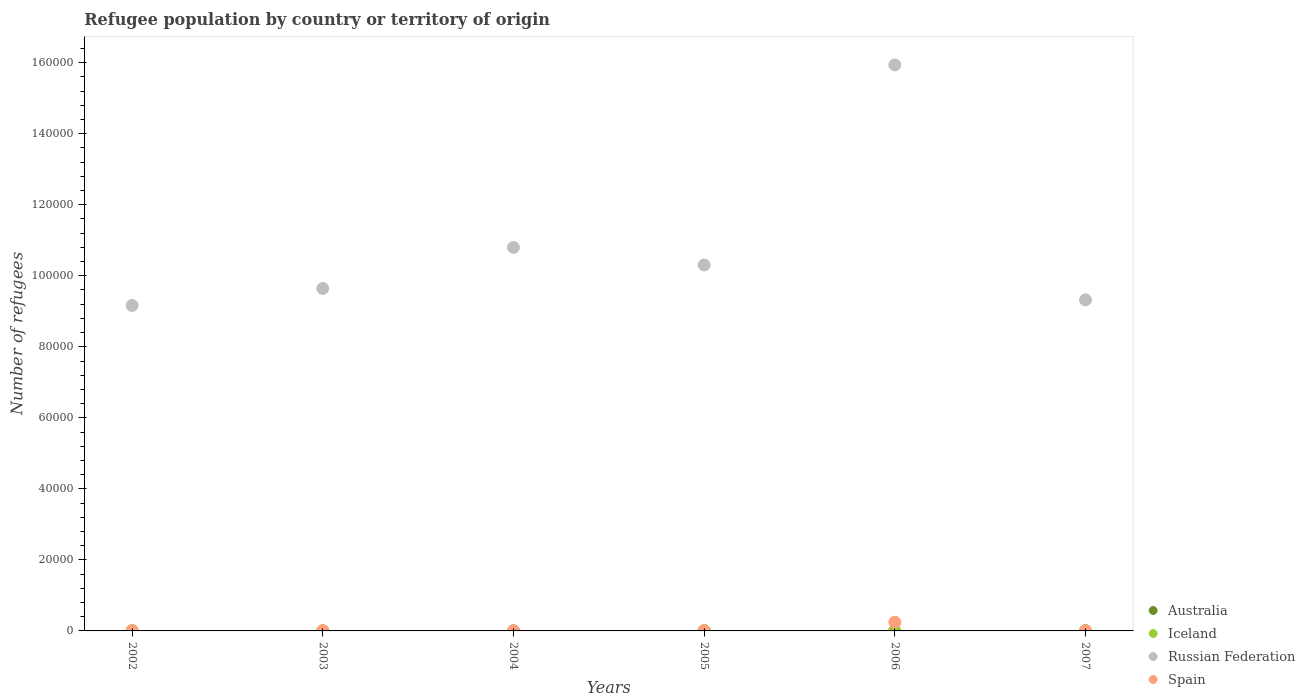In which year was the number of refugees in Australia maximum?
Offer a terse response. 2007. In which year was the number of refugees in Spain minimum?
Keep it short and to the point. 2007. What is the total number of refugees in Iceland in the graph?
Your answer should be very brief. 80. What is the difference between the number of refugees in Australia in 2003 and the number of refugees in Russian Federation in 2005?
Provide a short and direct response. -1.03e+05. In the year 2004, what is the difference between the number of refugees in Spain and number of refugees in Iceland?
Keep it short and to the point. 39. What is the ratio of the number of refugees in Iceland in 2002 to that in 2005?
Keep it short and to the point. 1.86. What is the difference between the highest and the second highest number of refugees in Russian Federation?
Give a very brief answer. 5.14e+04. What is the difference between the highest and the lowest number of refugees in Russian Federation?
Offer a very short reply. 6.78e+04. Is the sum of the number of refugees in Spain in 2003 and 2006 greater than the maximum number of refugees in Iceland across all years?
Make the answer very short. Yes. Is it the case that in every year, the sum of the number of refugees in Russian Federation and number of refugees in Iceland  is greater than the sum of number of refugees in Spain and number of refugees in Australia?
Offer a very short reply. Yes. Does the number of refugees in Spain monotonically increase over the years?
Your response must be concise. No. Is the number of refugees in Iceland strictly greater than the number of refugees in Australia over the years?
Provide a short and direct response. No. Is the number of refugees in Australia strictly less than the number of refugees in Iceland over the years?
Offer a very short reply. No. Are the values on the major ticks of Y-axis written in scientific E-notation?
Provide a short and direct response. No. Does the graph contain any zero values?
Offer a terse response. No. Does the graph contain grids?
Provide a succinct answer. No. How are the legend labels stacked?
Keep it short and to the point. Vertical. What is the title of the graph?
Your response must be concise. Refugee population by country or territory of origin. What is the label or title of the Y-axis?
Provide a short and direct response. Number of refugees. What is the Number of refugees of Iceland in 2002?
Your answer should be compact. 13. What is the Number of refugees in Russian Federation in 2002?
Provide a short and direct response. 9.16e+04. What is the Number of refugees of Australia in 2003?
Your answer should be very brief. 15. What is the Number of refugees in Russian Federation in 2003?
Give a very brief answer. 9.64e+04. What is the Number of refugees in Iceland in 2004?
Provide a short and direct response. 10. What is the Number of refugees in Russian Federation in 2004?
Provide a succinct answer. 1.08e+05. What is the Number of refugees of Spain in 2004?
Your answer should be compact. 49. What is the Number of refugees in Australia in 2005?
Give a very brief answer. 44. What is the Number of refugees in Iceland in 2005?
Offer a terse response. 7. What is the Number of refugees in Russian Federation in 2005?
Your answer should be compact. 1.03e+05. What is the Number of refugees in Russian Federation in 2006?
Keep it short and to the point. 1.59e+05. What is the Number of refugees of Spain in 2006?
Give a very brief answer. 2444. What is the Number of refugees of Iceland in 2007?
Your answer should be very brief. 7. What is the Number of refugees of Russian Federation in 2007?
Give a very brief answer. 9.32e+04. Across all years, what is the maximum Number of refugees of Australia?
Make the answer very short. 63. Across all years, what is the maximum Number of refugees in Russian Federation?
Your answer should be compact. 1.59e+05. Across all years, what is the maximum Number of refugees of Spain?
Your answer should be compact. 2444. Across all years, what is the minimum Number of refugees in Australia?
Offer a terse response. 10. Across all years, what is the minimum Number of refugees in Russian Federation?
Ensure brevity in your answer.  9.16e+04. What is the total Number of refugees in Australia in the graph?
Make the answer very short. 174. What is the total Number of refugees in Russian Federation in the graph?
Your answer should be very brief. 6.52e+05. What is the total Number of refugees in Spain in the graph?
Offer a very short reply. 2694. What is the difference between the Number of refugees in Australia in 2002 and that in 2003?
Offer a very short reply. -5. What is the difference between the Number of refugees of Iceland in 2002 and that in 2003?
Make the answer very short. 1. What is the difference between the Number of refugees in Russian Federation in 2002 and that in 2003?
Keep it short and to the point. -4794. What is the difference between the Number of refugees in Spain in 2002 and that in 2003?
Provide a short and direct response. 5. What is the difference between the Number of refugees in Iceland in 2002 and that in 2004?
Offer a terse response. 3. What is the difference between the Number of refugees of Russian Federation in 2002 and that in 2004?
Your answer should be compact. -1.63e+04. What is the difference between the Number of refugees of Australia in 2002 and that in 2005?
Your answer should be very brief. -34. What is the difference between the Number of refugees in Iceland in 2002 and that in 2005?
Your answer should be very brief. 6. What is the difference between the Number of refugees in Russian Federation in 2002 and that in 2005?
Make the answer very short. -1.14e+04. What is the difference between the Number of refugees in Spain in 2002 and that in 2005?
Your answer should be very brief. 9. What is the difference between the Number of refugees of Australia in 2002 and that in 2006?
Your response must be concise. -19. What is the difference between the Number of refugees of Russian Federation in 2002 and that in 2006?
Your response must be concise. -6.78e+04. What is the difference between the Number of refugees in Spain in 2002 and that in 2006?
Provide a succinct answer. -2386. What is the difference between the Number of refugees in Australia in 2002 and that in 2007?
Offer a very short reply. -53. What is the difference between the Number of refugees of Iceland in 2002 and that in 2007?
Provide a short and direct response. 6. What is the difference between the Number of refugees in Russian Federation in 2002 and that in 2007?
Ensure brevity in your answer.  -1598. What is the difference between the Number of refugees in Iceland in 2003 and that in 2004?
Your response must be concise. 2. What is the difference between the Number of refugees in Russian Federation in 2003 and that in 2004?
Offer a very short reply. -1.16e+04. What is the difference between the Number of refugees of Spain in 2003 and that in 2004?
Make the answer very short. 4. What is the difference between the Number of refugees in Iceland in 2003 and that in 2005?
Keep it short and to the point. 5. What is the difference between the Number of refugees in Russian Federation in 2003 and that in 2005?
Offer a terse response. -6617. What is the difference between the Number of refugees of Iceland in 2003 and that in 2006?
Your response must be concise. -19. What is the difference between the Number of refugees in Russian Federation in 2003 and that in 2006?
Offer a terse response. -6.30e+04. What is the difference between the Number of refugees in Spain in 2003 and that in 2006?
Make the answer very short. -2391. What is the difference between the Number of refugees in Australia in 2003 and that in 2007?
Ensure brevity in your answer.  -48. What is the difference between the Number of refugees of Iceland in 2003 and that in 2007?
Offer a terse response. 5. What is the difference between the Number of refugees of Russian Federation in 2003 and that in 2007?
Provide a short and direct response. 3196. What is the difference between the Number of refugees in Spain in 2003 and that in 2007?
Offer a terse response. 12. What is the difference between the Number of refugees of Australia in 2004 and that in 2005?
Your answer should be very brief. -31. What is the difference between the Number of refugees in Iceland in 2004 and that in 2005?
Ensure brevity in your answer.  3. What is the difference between the Number of refugees of Russian Federation in 2004 and that in 2005?
Provide a short and direct response. 4938. What is the difference between the Number of refugees of Australia in 2004 and that in 2006?
Offer a terse response. -16. What is the difference between the Number of refugees in Iceland in 2004 and that in 2006?
Your answer should be very brief. -21. What is the difference between the Number of refugees of Russian Federation in 2004 and that in 2006?
Keep it short and to the point. -5.14e+04. What is the difference between the Number of refugees of Spain in 2004 and that in 2006?
Offer a very short reply. -2395. What is the difference between the Number of refugees in Australia in 2004 and that in 2007?
Make the answer very short. -50. What is the difference between the Number of refugees in Russian Federation in 2004 and that in 2007?
Your response must be concise. 1.48e+04. What is the difference between the Number of refugees of Spain in 2004 and that in 2007?
Your response must be concise. 8. What is the difference between the Number of refugees in Australia in 2005 and that in 2006?
Your answer should be very brief. 15. What is the difference between the Number of refugees in Iceland in 2005 and that in 2006?
Make the answer very short. -24. What is the difference between the Number of refugees in Russian Federation in 2005 and that in 2006?
Offer a terse response. -5.63e+04. What is the difference between the Number of refugees of Spain in 2005 and that in 2006?
Your answer should be very brief. -2395. What is the difference between the Number of refugees in Iceland in 2005 and that in 2007?
Ensure brevity in your answer.  0. What is the difference between the Number of refugees in Russian Federation in 2005 and that in 2007?
Your answer should be compact. 9813. What is the difference between the Number of refugees of Australia in 2006 and that in 2007?
Keep it short and to the point. -34. What is the difference between the Number of refugees of Iceland in 2006 and that in 2007?
Your answer should be very brief. 24. What is the difference between the Number of refugees in Russian Federation in 2006 and that in 2007?
Your response must be concise. 6.62e+04. What is the difference between the Number of refugees of Spain in 2006 and that in 2007?
Provide a succinct answer. 2403. What is the difference between the Number of refugees in Australia in 2002 and the Number of refugees in Iceland in 2003?
Provide a succinct answer. -2. What is the difference between the Number of refugees in Australia in 2002 and the Number of refugees in Russian Federation in 2003?
Keep it short and to the point. -9.64e+04. What is the difference between the Number of refugees in Australia in 2002 and the Number of refugees in Spain in 2003?
Provide a short and direct response. -43. What is the difference between the Number of refugees of Iceland in 2002 and the Number of refugees of Russian Federation in 2003?
Provide a short and direct response. -9.64e+04. What is the difference between the Number of refugees in Iceland in 2002 and the Number of refugees in Spain in 2003?
Your response must be concise. -40. What is the difference between the Number of refugees in Russian Federation in 2002 and the Number of refugees in Spain in 2003?
Make the answer very short. 9.16e+04. What is the difference between the Number of refugees in Australia in 2002 and the Number of refugees in Iceland in 2004?
Ensure brevity in your answer.  0. What is the difference between the Number of refugees in Australia in 2002 and the Number of refugees in Russian Federation in 2004?
Your answer should be compact. -1.08e+05. What is the difference between the Number of refugees in Australia in 2002 and the Number of refugees in Spain in 2004?
Provide a succinct answer. -39. What is the difference between the Number of refugees of Iceland in 2002 and the Number of refugees of Russian Federation in 2004?
Ensure brevity in your answer.  -1.08e+05. What is the difference between the Number of refugees in Iceland in 2002 and the Number of refugees in Spain in 2004?
Make the answer very short. -36. What is the difference between the Number of refugees in Russian Federation in 2002 and the Number of refugees in Spain in 2004?
Keep it short and to the point. 9.16e+04. What is the difference between the Number of refugees in Australia in 2002 and the Number of refugees in Russian Federation in 2005?
Offer a very short reply. -1.03e+05. What is the difference between the Number of refugees of Australia in 2002 and the Number of refugees of Spain in 2005?
Provide a short and direct response. -39. What is the difference between the Number of refugees in Iceland in 2002 and the Number of refugees in Russian Federation in 2005?
Offer a very short reply. -1.03e+05. What is the difference between the Number of refugees in Iceland in 2002 and the Number of refugees in Spain in 2005?
Give a very brief answer. -36. What is the difference between the Number of refugees of Russian Federation in 2002 and the Number of refugees of Spain in 2005?
Make the answer very short. 9.16e+04. What is the difference between the Number of refugees of Australia in 2002 and the Number of refugees of Russian Federation in 2006?
Provide a short and direct response. -1.59e+05. What is the difference between the Number of refugees in Australia in 2002 and the Number of refugees in Spain in 2006?
Your answer should be compact. -2434. What is the difference between the Number of refugees of Iceland in 2002 and the Number of refugees of Russian Federation in 2006?
Provide a short and direct response. -1.59e+05. What is the difference between the Number of refugees of Iceland in 2002 and the Number of refugees of Spain in 2006?
Your response must be concise. -2431. What is the difference between the Number of refugees in Russian Federation in 2002 and the Number of refugees in Spain in 2006?
Make the answer very short. 8.92e+04. What is the difference between the Number of refugees in Australia in 2002 and the Number of refugees in Iceland in 2007?
Make the answer very short. 3. What is the difference between the Number of refugees in Australia in 2002 and the Number of refugees in Russian Federation in 2007?
Provide a succinct answer. -9.32e+04. What is the difference between the Number of refugees in Australia in 2002 and the Number of refugees in Spain in 2007?
Your answer should be very brief. -31. What is the difference between the Number of refugees of Iceland in 2002 and the Number of refugees of Russian Federation in 2007?
Give a very brief answer. -9.32e+04. What is the difference between the Number of refugees of Iceland in 2002 and the Number of refugees of Spain in 2007?
Offer a very short reply. -28. What is the difference between the Number of refugees of Russian Federation in 2002 and the Number of refugees of Spain in 2007?
Your response must be concise. 9.16e+04. What is the difference between the Number of refugees of Australia in 2003 and the Number of refugees of Iceland in 2004?
Provide a succinct answer. 5. What is the difference between the Number of refugees of Australia in 2003 and the Number of refugees of Russian Federation in 2004?
Give a very brief answer. -1.08e+05. What is the difference between the Number of refugees of Australia in 2003 and the Number of refugees of Spain in 2004?
Provide a short and direct response. -34. What is the difference between the Number of refugees of Iceland in 2003 and the Number of refugees of Russian Federation in 2004?
Your response must be concise. -1.08e+05. What is the difference between the Number of refugees in Iceland in 2003 and the Number of refugees in Spain in 2004?
Make the answer very short. -37. What is the difference between the Number of refugees of Russian Federation in 2003 and the Number of refugees of Spain in 2004?
Give a very brief answer. 9.64e+04. What is the difference between the Number of refugees of Australia in 2003 and the Number of refugees of Iceland in 2005?
Give a very brief answer. 8. What is the difference between the Number of refugees in Australia in 2003 and the Number of refugees in Russian Federation in 2005?
Offer a very short reply. -1.03e+05. What is the difference between the Number of refugees in Australia in 2003 and the Number of refugees in Spain in 2005?
Your response must be concise. -34. What is the difference between the Number of refugees in Iceland in 2003 and the Number of refugees in Russian Federation in 2005?
Offer a very short reply. -1.03e+05. What is the difference between the Number of refugees of Iceland in 2003 and the Number of refugees of Spain in 2005?
Provide a succinct answer. -37. What is the difference between the Number of refugees in Russian Federation in 2003 and the Number of refugees in Spain in 2005?
Keep it short and to the point. 9.64e+04. What is the difference between the Number of refugees of Australia in 2003 and the Number of refugees of Russian Federation in 2006?
Make the answer very short. -1.59e+05. What is the difference between the Number of refugees in Australia in 2003 and the Number of refugees in Spain in 2006?
Offer a terse response. -2429. What is the difference between the Number of refugees of Iceland in 2003 and the Number of refugees of Russian Federation in 2006?
Provide a succinct answer. -1.59e+05. What is the difference between the Number of refugees in Iceland in 2003 and the Number of refugees in Spain in 2006?
Provide a short and direct response. -2432. What is the difference between the Number of refugees in Russian Federation in 2003 and the Number of refugees in Spain in 2006?
Your answer should be very brief. 9.40e+04. What is the difference between the Number of refugees of Australia in 2003 and the Number of refugees of Iceland in 2007?
Keep it short and to the point. 8. What is the difference between the Number of refugees in Australia in 2003 and the Number of refugees in Russian Federation in 2007?
Keep it short and to the point. -9.32e+04. What is the difference between the Number of refugees of Australia in 2003 and the Number of refugees of Spain in 2007?
Provide a succinct answer. -26. What is the difference between the Number of refugees of Iceland in 2003 and the Number of refugees of Russian Federation in 2007?
Offer a very short reply. -9.32e+04. What is the difference between the Number of refugees in Russian Federation in 2003 and the Number of refugees in Spain in 2007?
Provide a short and direct response. 9.64e+04. What is the difference between the Number of refugees in Australia in 2004 and the Number of refugees in Russian Federation in 2005?
Make the answer very short. -1.03e+05. What is the difference between the Number of refugees of Australia in 2004 and the Number of refugees of Spain in 2005?
Keep it short and to the point. -36. What is the difference between the Number of refugees of Iceland in 2004 and the Number of refugees of Russian Federation in 2005?
Your answer should be compact. -1.03e+05. What is the difference between the Number of refugees of Iceland in 2004 and the Number of refugees of Spain in 2005?
Provide a short and direct response. -39. What is the difference between the Number of refugees of Russian Federation in 2004 and the Number of refugees of Spain in 2005?
Your answer should be compact. 1.08e+05. What is the difference between the Number of refugees of Australia in 2004 and the Number of refugees of Russian Federation in 2006?
Your answer should be compact. -1.59e+05. What is the difference between the Number of refugees in Australia in 2004 and the Number of refugees in Spain in 2006?
Offer a terse response. -2431. What is the difference between the Number of refugees of Iceland in 2004 and the Number of refugees of Russian Federation in 2006?
Provide a short and direct response. -1.59e+05. What is the difference between the Number of refugees in Iceland in 2004 and the Number of refugees in Spain in 2006?
Your answer should be very brief. -2434. What is the difference between the Number of refugees in Russian Federation in 2004 and the Number of refugees in Spain in 2006?
Offer a very short reply. 1.06e+05. What is the difference between the Number of refugees in Australia in 2004 and the Number of refugees in Russian Federation in 2007?
Provide a succinct answer. -9.32e+04. What is the difference between the Number of refugees of Iceland in 2004 and the Number of refugees of Russian Federation in 2007?
Offer a very short reply. -9.32e+04. What is the difference between the Number of refugees in Iceland in 2004 and the Number of refugees in Spain in 2007?
Offer a very short reply. -31. What is the difference between the Number of refugees in Russian Federation in 2004 and the Number of refugees in Spain in 2007?
Your response must be concise. 1.08e+05. What is the difference between the Number of refugees of Australia in 2005 and the Number of refugees of Iceland in 2006?
Your answer should be compact. 13. What is the difference between the Number of refugees in Australia in 2005 and the Number of refugees in Russian Federation in 2006?
Offer a terse response. -1.59e+05. What is the difference between the Number of refugees in Australia in 2005 and the Number of refugees in Spain in 2006?
Your response must be concise. -2400. What is the difference between the Number of refugees of Iceland in 2005 and the Number of refugees of Russian Federation in 2006?
Your answer should be compact. -1.59e+05. What is the difference between the Number of refugees in Iceland in 2005 and the Number of refugees in Spain in 2006?
Your response must be concise. -2437. What is the difference between the Number of refugees in Russian Federation in 2005 and the Number of refugees in Spain in 2006?
Provide a short and direct response. 1.01e+05. What is the difference between the Number of refugees in Australia in 2005 and the Number of refugees in Russian Federation in 2007?
Give a very brief answer. -9.32e+04. What is the difference between the Number of refugees of Iceland in 2005 and the Number of refugees of Russian Federation in 2007?
Provide a succinct answer. -9.32e+04. What is the difference between the Number of refugees of Iceland in 2005 and the Number of refugees of Spain in 2007?
Provide a short and direct response. -34. What is the difference between the Number of refugees of Russian Federation in 2005 and the Number of refugees of Spain in 2007?
Keep it short and to the point. 1.03e+05. What is the difference between the Number of refugees of Australia in 2006 and the Number of refugees of Iceland in 2007?
Your response must be concise. 22. What is the difference between the Number of refugees in Australia in 2006 and the Number of refugees in Russian Federation in 2007?
Your response must be concise. -9.32e+04. What is the difference between the Number of refugees of Australia in 2006 and the Number of refugees of Spain in 2007?
Offer a very short reply. -12. What is the difference between the Number of refugees in Iceland in 2006 and the Number of refugees in Russian Federation in 2007?
Your answer should be compact. -9.32e+04. What is the difference between the Number of refugees of Russian Federation in 2006 and the Number of refugees of Spain in 2007?
Provide a succinct answer. 1.59e+05. What is the average Number of refugees of Iceland per year?
Ensure brevity in your answer.  13.33. What is the average Number of refugees in Russian Federation per year?
Your answer should be very brief. 1.09e+05. What is the average Number of refugees of Spain per year?
Your response must be concise. 449. In the year 2002, what is the difference between the Number of refugees of Australia and Number of refugees of Iceland?
Ensure brevity in your answer.  -3. In the year 2002, what is the difference between the Number of refugees in Australia and Number of refugees in Russian Federation?
Give a very brief answer. -9.16e+04. In the year 2002, what is the difference between the Number of refugees of Australia and Number of refugees of Spain?
Provide a short and direct response. -48. In the year 2002, what is the difference between the Number of refugees of Iceland and Number of refugees of Russian Federation?
Provide a succinct answer. -9.16e+04. In the year 2002, what is the difference between the Number of refugees of Iceland and Number of refugees of Spain?
Offer a terse response. -45. In the year 2002, what is the difference between the Number of refugees of Russian Federation and Number of refugees of Spain?
Your answer should be compact. 9.16e+04. In the year 2003, what is the difference between the Number of refugees of Australia and Number of refugees of Russian Federation?
Give a very brief answer. -9.64e+04. In the year 2003, what is the difference between the Number of refugees in Australia and Number of refugees in Spain?
Your response must be concise. -38. In the year 2003, what is the difference between the Number of refugees of Iceland and Number of refugees of Russian Federation?
Keep it short and to the point. -9.64e+04. In the year 2003, what is the difference between the Number of refugees in Iceland and Number of refugees in Spain?
Provide a short and direct response. -41. In the year 2003, what is the difference between the Number of refugees in Russian Federation and Number of refugees in Spain?
Your response must be concise. 9.64e+04. In the year 2004, what is the difference between the Number of refugees in Australia and Number of refugees in Iceland?
Your answer should be very brief. 3. In the year 2004, what is the difference between the Number of refugees of Australia and Number of refugees of Russian Federation?
Provide a short and direct response. -1.08e+05. In the year 2004, what is the difference between the Number of refugees of Australia and Number of refugees of Spain?
Give a very brief answer. -36. In the year 2004, what is the difference between the Number of refugees in Iceland and Number of refugees in Russian Federation?
Offer a terse response. -1.08e+05. In the year 2004, what is the difference between the Number of refugees in Iceland and Number of refugees in Spain?
Keep it short and to the point. -39. In the year 2004, what is the difference between the Number of refugees in Russian Federation and Number of refugees in Spain?
Offer a very short reply. 1.08e+05. In the year 2005, what is the difference between the Number of refugees of Australia and Number of refugees of Iceland?
Your answer should be very brief. 37. In the year 2005, what is the difference between the Number of refugees in Australia and Number of refugees in Russian Federation?
Keep it short and to the point. -1.03e+05. In the year 2005, what is the difference between the Number of refugees of Australia and Number of refugees of Spain?
Give a very brief answer. -5. In the year 2005, what is the difference between the Number of refugees in Iceland and Number of refugees in Russian Federation?
Offer a terse response. -1.03e+05. In the year 2005, what is the difference between the Number of refugees in Iceland and Number of refugees in Spain?
Make the answer very short. -42. In the year 2005, what is the difference between the Number of refugees of Russian Federation and Number of refugees of Spain?
Ensure brevity in your answer.  1.03e+05. In the year 2006, what is the difference between the Number of refugees in Australia and Number of refugees in Russian Federation?
Offer a very short reply. -1.59e+05. In the year 2006, what is the difference between the Number of refugees in Australia and Number of refugees in Spain?
Make the answer very short. -2415. In the year 2006, what is the difference between the Number of refugees in Iceland and Number of refugees in Russian Federation?
Your answer should be compact. -1.59e+05. In the year 2006, what is the difference between the Number of refugees in Iceland and Number of refugees in Spain?
Your answer should be compact. -2413. In the year 2006, what is the difference between the Number of refugees of Russian Federation and Number of refugees of Spain?
Offer a terse response. 1.57e+05. In the year 2007, what is the difference between the Number of refugees in Australia and Number of refugees in Iceland?
Your answer should be compact. 56. In the year 2007, what is the difference between the Number of refugees in Australia and Number of refugees in Russian Federation?
Offer a terse response. -9.32e+04. In the year 2007, what is the difference between the Number of refugees of Australia and Number of refugees of Spain?
Your answer should be compact. 22. In the year 2007, what is the difference between the Number of refugees in Iceland and Number of refugees in Russian Federation?
Keep it short and to the point. -9.32e+04. In the year 2007, what is the difference between the Number of refugees in Iceland and Number of refugees in Spain?
Offer a very short reply. -34. In the year 2007, what is the difference between the Number of refugees in Russian Federation and Number of refugees in Spain?
Offer a very short reply. 9.32e+04. What is the ratio of the Number of refugees of Australia in 2002 to that in 2003?
Offer a terse response. 0.67. What is the ratio of the Number of refugees in Russian Federation in 2002 to that in 2003?
Offer a terse response. 0.95. What is the ratio of the Number of refugees in Spain in 2002 to that in 2003?
Give a very brief answer. 1.09. What is the ratio of the Number of refugees in Australia in 2002 to that in 2004?
Give a very brief answer. 0.77. What is the ratio of the Number of refugees in Russian Federation in 2002 to that in 2004?
Provide a succinct answer. 0.85. What is the ratio of the Number of refugees of Spain in 2002 to that in 2004?
Give a very brief answer. 1.18. What is the ratio of the Number of refugees in Australia in 2002 to that in 2005?
Provide a short and direct response. 0.23. What is the ratio of the Number of refugees in Iceland in 2002 to that in 2005?
Keep it short and to the point. 1.86. What is the ratio of the Number of refugees in Russian Federation in 2002 to that in 2005?
Your response must be concise. 0.89. What is the ratio of the Number of refugees in Spain in 2002 to that in 2005?
Give a very brief answer. 1.18. What is the ratio of the Number of refugees of Australia in 2002 to that in 2006?
Your response must be concise. 0.34. What is the ratio of the Number of refugees in Iceland in 2002 to that in 2006?
Provide a short and direct response. 0.42. What is the ratio of the Number of refugees in Russian Federation in 2002 to that in 2006?
Make the answer very short. 0.57. What is the ratio of the Number of refugees in Spain in 2002 to that in 2006?
Your response must be concise. 0.02. What is the ratio of the Number of refugees of Australia in 2002 to that in 2007?
Make the answer very short. 0.16. What is the ratio of the Number of refugees in Iceland in 2002 to that in 2007?
Give a very brief answer. 1.86. What is the ratio of the Number of refugees in Russian Federation in 2002 to that in 2007?
Give a very brief answer. 0.98. What is the ratio of the Number of refugees of Spain in 2002 to that in 2007?
Keep it short and to the point. 1.41. What is the ratio of the Number of refugees in Australia in 2003 to that in 2004?
Your answer should be very brief. 1.15. What is the ratio of the Number of refugees in Russian Federation in 2003 to that in 2004?
Keep it short and to the point. 0.89. What is the ratio of the Number of refugees of Spain in 2003 to that in 2004?
Keep it short and to the point. 1.08. What is the ratio of the Number of refugees of Australia in 2003 to that in 2005?
Your response must be concise. 0.34. What is the ratio of the Number of refugees in Iceland in 2003 to that in 2005?
Ensure brevity in your answer.  1.71. What is the ratio of the Number of refugees in Russian Federation in 2003 to that in 2005?
Offer a terse response. 0.94. What is the ratio of the Number of refugees of Spain in 2003 to that in 2005?
Ensure brevity in your answer.  1.08. What is the ratio of the Number of refugees of Australia in 2003 to that in 2006?
Make the answer very short. 0.52. What is the ratio of the Number of refugees in Iceland in 2003 to that in 2006?
Offer a very short reply. 0.39. What is the ratio of the Number of refugees in Russian Federation in 2003 to that in 2006?
Make the answer very short. 0.6. What is the ratio of the Number of refugees of Spain in 2003 to that in 2006?
Ensure brevity in your answer.  0.02. What is the ratio of the Number of refugees of Australia in 2003 to that in 2007?
Offer a very short reply. 0.24. What is the ratio of the Number of refugees of Iceland in 2003 to that in 2007?
Make the answer very short. 1.71. What is the ratio of the Number of refugees in Russian Federation in 2003 to that in 2007?
Provide a succinct answer. 1.03. What is the ratio of the Number of refugees in Spain in 2003 to that in 2007?
Give a very brief answer. 1.29. What is the ratio of the Number of refugees in Australia in 2004 to that in 2005?
Your answer should be very brief. 0.3. What is the ratio of the Number of refugees in Iceland in 2004 to that in 2005?
Provide a succinct answer. 1.43. What is the ratio of the Number of refugees in Russian Federation in 2004 to that in 2005?
Keep it short and to the point. 1.05. What is the ratio of the Number of refugees of Spain in 2004 to that in 2005?
Your answer should be compact. 1. What is the ratio of the Number of refugees in Australia in 2004 to that in 2006?
Offer a terse response. 0.45. What is the ratio of the Number of refugees of Iceland in 2004 to that in 2006?
Give a very brief answer. 0.32. What is the ratio of the Number of refugees of Russian Federation in 2004 to that in 2006?
Provide a short and direct response. 0.68. What is the ratio of the Number of refugees of Spain in 2004 to that in 2006?
Your answer should be very brief. 0.02. What is the ratio of the Number of refugees in Australia in 2004 to that in 2007?
Keep it short and to the point. 0.21. What is the ratio of the Number of refugees of Iceland in 2004 to that in 2007?
Ensure brevity in your answer.  1.43. What is the ratio of the Number of refugees of Russian Federation in 2004 to that in 2007?
Provide a succinct answer. 1.16. What is the ratio of the Number of refugees of Spain in 2004 to that in 2007?
Offer a terse response. 1.2. What is the ratio of the Number of refugees in Australia in 2005 to that in 2006?
Offer a very short reply. 1.52. What is the ratio of the Number of refugees of Iceland in 2005 to that in 2006?
Keep it short and to the point. 0.23. What is the ratio of the Number of refugees of Russian Federation in 2005 to that in 2006?
Make the answer very short. 0.65. What is the ratio of the Number of refugees in Spain in 2005 to that in 2006?
Provide a short and direct response. 0.02. What is the ratio of the Number of refugees of Australia in 2005 to that in 2007?
Give a very brief answer. 0.7. What is the ratio of the Number of refugees of Iceland in 2005 to that in 2007?
Your answer should be very brief. 1. What is the ratio of the Number of refugees of Russian Federation in 2005 to that in 2007?
Provide a succinct answer. 1.11. What is the ratio of the Number of refugees in Spain in 2005 to that in 2007?
Your answer should be compact. 1.2. What is the ratio of the Number of refugees of Australia in 2006 to that in 2007?
Your response must be concise. 0.46. What is the ratio of the Number of refugees of Iceland in 2006 to that in 2007?
Give a very brief answer. 4.43. What is the ratio of the Number of refugees of Russian Federation in 2006 to that in 2007?
Keep it short and to the point. 1.71. What is the ratio of the Number of refugees in Spain in 2006 to that in 2007?
Keep it short and to the point. 59.61. What is the difference between the highest and the second highest Number of refugees in Australia?
Provide a short and direct response. 19. What is the difference between the highest and the second highest Number of refugees of Russian Federation?
Offer a very short reply. 5.14e+04. What is the difference between the highest and the second highest Number of refugees in Spain?
Make the answer very short. 2386. What is the difference between the highest and the lowest Number of refugees in Australia?
Make the answer very short. 53. What is the difference between the highest and the lowest Number of refugees in Iceland?
Ensure brevity in your answer.  24. What is the difference between the highest and the lowest Number of refugees in Russian Federation?
Your response must be concise. 6.78e+04. What is the difference between the highest and the lowest Number of refugees of Spain?
Offer a terse response. 2403. 